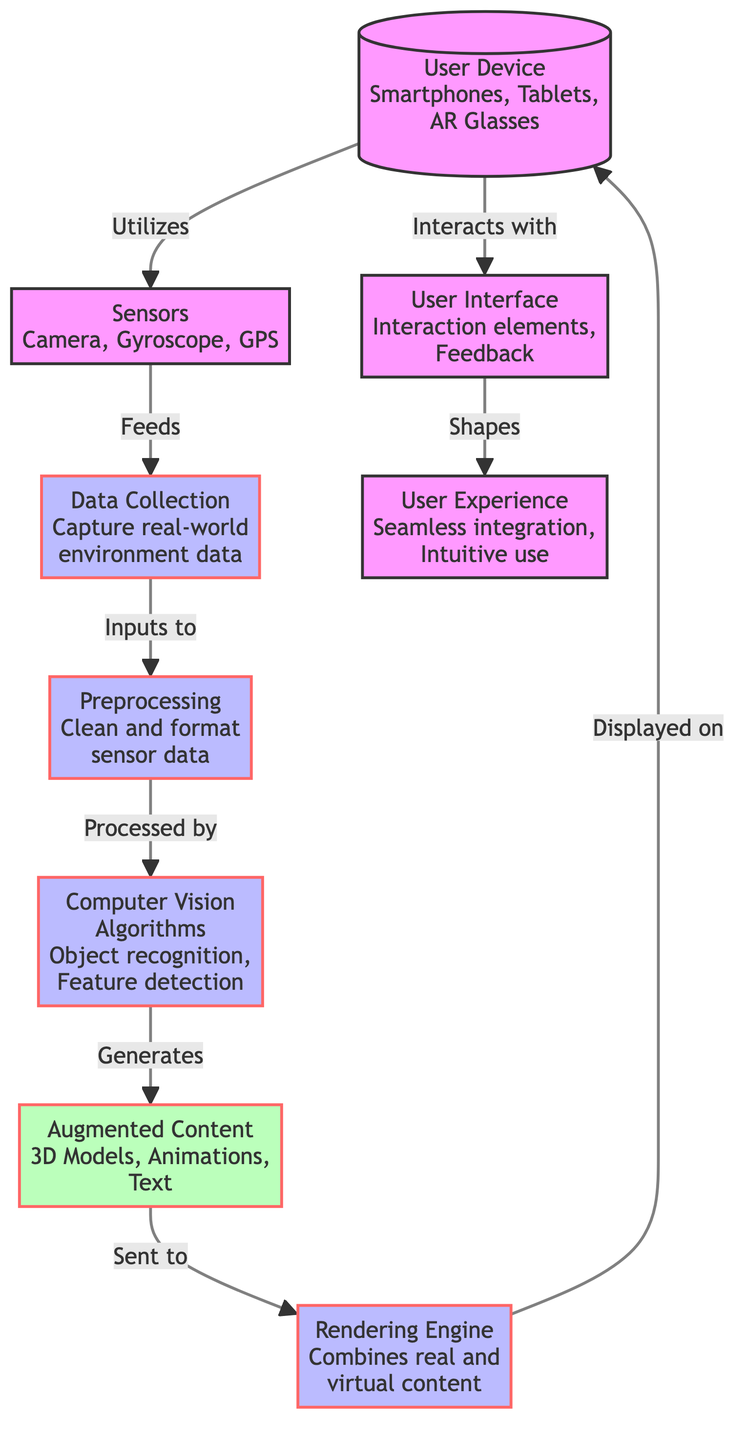What type of devices utilize the components in this flowchart? The flowchart indicates that the starting point is the "User Device," which includes smartphones, tablets, and AR glasses as examples of devices that utilize the subsequent components.
Answer: Smartphones, Tablets, AR Glasses How many sensors are mentioned in the diagram? According to the diagram, there are three sensors listed: the camera, gyroscope, and GPS. Counting these gives a total of three sensors.
Answer: 3 What does the "User Device" interact with? The diagram specifies that the "User Device" interacts with the "User Interface," indicating the relationship between these two components as a form of interaction.
Answer: User Interface What is generated by the "Computer Vision" algorithms? The diagram details that the "Computer Vision Algorithms" are responsible for generating "Augmented Content," which consists of 3D models, animations, and text.
Answer: Augmented Content What is the flow of data from "Data Collection" to "Rendering Engine"? The flow starts at "Data Collection" where real-world environment data is captured, which then feeds into "Preprocessing." After preprocessing, the data is processed by "Computer Vision Algorithms," which generate "Augmented Content." Finally, this content is sent to the "Rendering Engine" for integration and display.
Answer: Data flows from Data Collection to Preprocessing, to Computer Vision, to Augmented Content, to Rendering Engine How does the "User Interface" influence the "User Experience"? The diagram states that the "User Interface" shapes the "User Experience." This indicates a direct relationship where the elements of interaction and feedback offered in the interface play a crucial role in defining how the user perceives and interacts with the application.
Answer: Shapes What does the "Rendering Engine" do with the augmented content? The diagram illustrates that the "Rendering Engine" combines real and virtual content, which means it takes the generated augmented content and blends it with the real-world data captured by the sensors.
Answer: Combines real and virtual content What is involved in the "Preprocessing" step? The "Preprocessing" stage includes the tasks of cleaning and formatting sensor data. This step is critical to prepare the raw data for subsequent processing and analysis in the flowchart.
Answer: Clean and format sensor data What type of feedback elements are mentioned in the "User Interface"? The diagram highlights that the "User Interface" contains interaction elements and feedback, suggesting that these are essential components that facilitate user interaction and response within the application.
Answer: Interaction elements, Feedback 